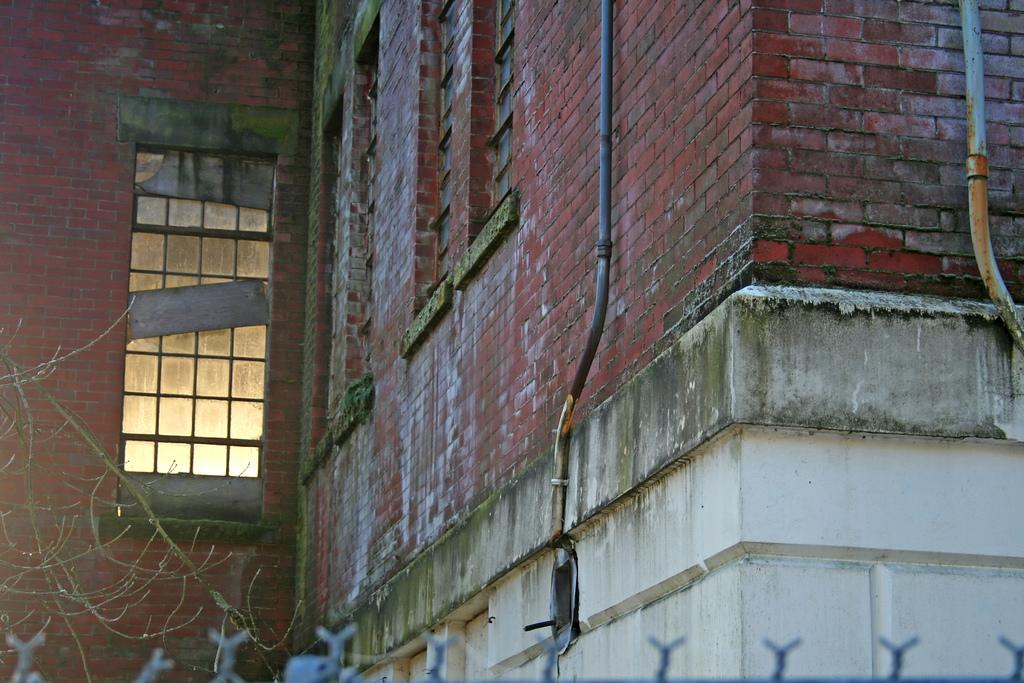What type of structure is present in the image? There is a building in the image. What can be seen attached to the building? There are pipes and windows visible in the image. What type of vegetation is present in the image? There are branches in the image. Can you tell me how the cook is breathing in the image? There is no cook present in the image, so it is not possible to determine how they might be breathing. 